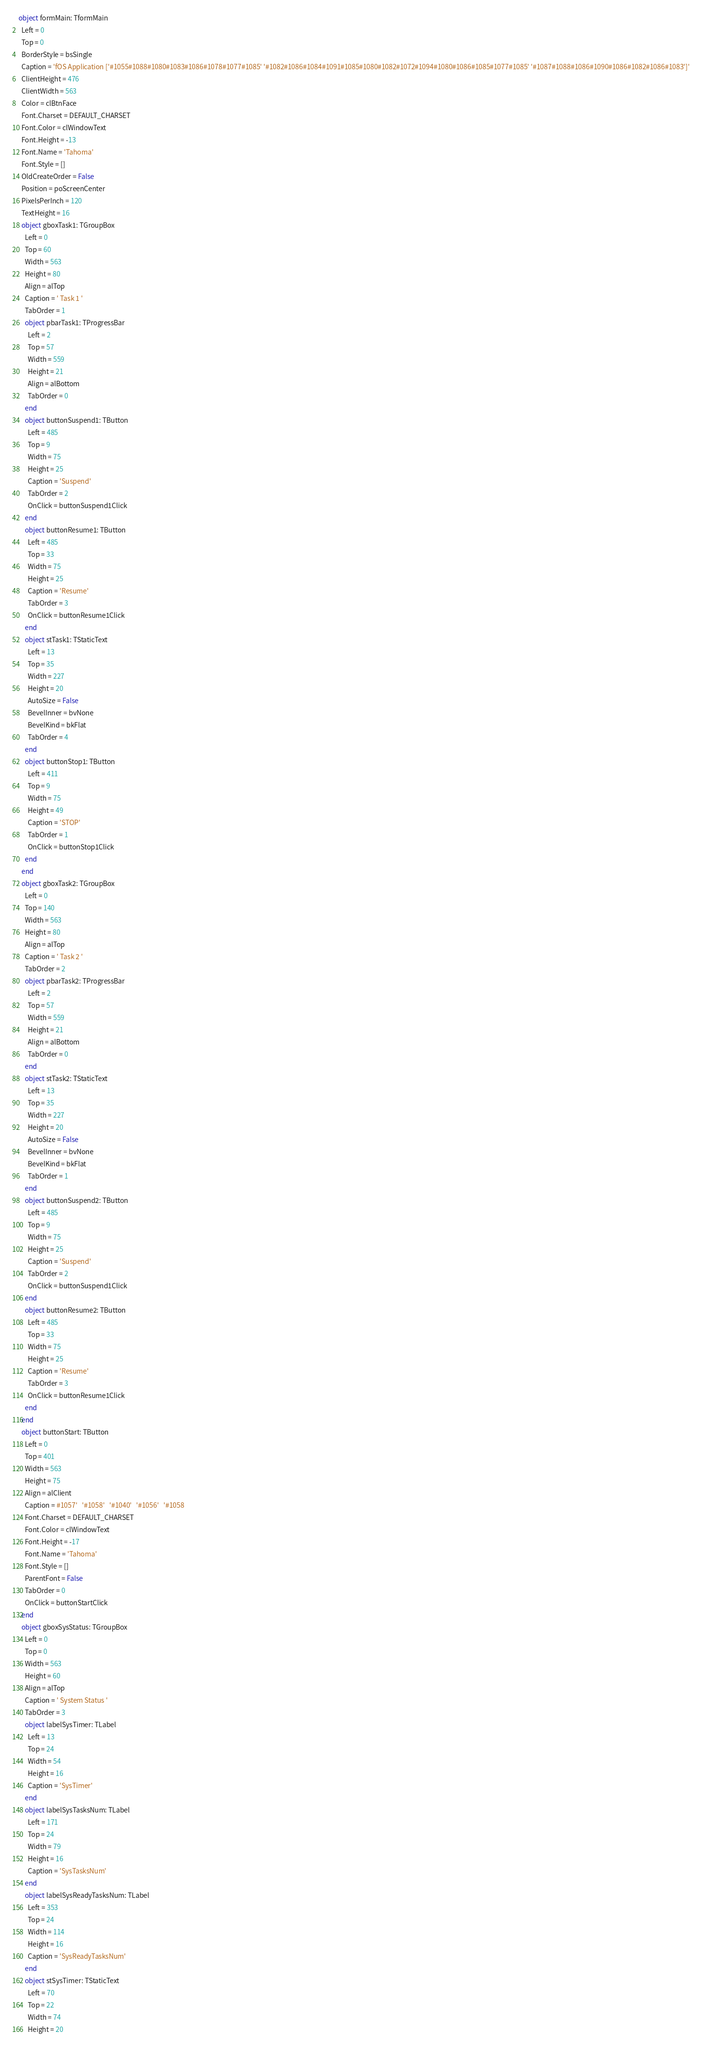<code> <loc_0><loc_0><loc_500><loc_500><_Pascal_>object formMain: TformMain
  Left = 0
  Top = 0
  BorderStyle = bsSingle
  Caption = 'fOS Application ['#1055#1088#1080#1083#1086#1078#1077#1085' '#1082#1086#1084#1091#1085#1080#1082#1072#1094#1080#1086#1085#1077#1085' '#1087#1088#1086#1090#1086#1082#1086#1083']'
  ClientHeight = 476
  ClientWidth = 563
  Color = clBtnFace
  Font.Charset = DEFAULT_CHARSET
  Font.Color = clWindowText
  Font.Height = -13
  Font.Name = 'Tahoma'
  Font.Style = []
  OldCreateOrder = False
  Position = poScreenCenter
  PixelsPerInch = 120
  TextHeight = 16
  object gboxTask1: TGroupBox
    Left = 0
    Top = 60
    Width = 563
    Height = 80
    Align = alTop
    Caption = ' Task 1 '
    TabOrder = 1
    object pbarTask1: TProgressBar
      Left = 2
      Top = 57
      Width = 559
      Height = 21
      Align = alBottom
      TabOrder = 0
    end
    object buttonSuspend1: TButton
      Left = 485
      Top = 9
      Width = 75
      Height = 25
      Caption = 'Suspend'
      TabOrder = 2
      OnClick = buttonSuspend1Click
    end
    object buttonResume1: TButton
      Left = 485
      Top = 33
      Width = 75
      Height = 25
      Caption = 'Resume'
      TabOrder = 3
      OnClick = buttonResume1Click
    end
    object stTask1: TStaticText
      Left = 13
      Top = 35
      Width = 227
      Height = 20
      AutoSize = False
      BevelInner = bvNone
      BevelKind = bkFlat
      TabOrder = 4
    end
    object buttonStop1: TButton
      Left = 411
      Top = 9
      Width = 75
      Height = 49
      Caption = 'STOP'
      TabOrder = 1
      OnClick = buttonStop1Click
    end
  end
  object gboxTask2: TGroupBox
    Left = 0
    Top = 140
    Width = 563
    Height = 80
    Align = alTop
    Caption = ' Task 2 '
    TabOrder = 2
    object pbarTask2: TProgressBar
      Left = 2
      Top = 57
      Width = 559
      Height = 21
      Align = alBottom
      TabOrder = 0
    end
    object stTask2: TStaticText
      Left = 13
      Top = 35
      Width = 227
      Height = 20
      AutoSize = False
      BevelInner = bvNone
      BevelKind = bkFlat
      TabOrder = 1
    end
    object buttonSuspend2: TButton
      Left = 485
      Top = 9
      Width = 75
      Height = 25
      Caption = 'Suspend'
      TabOrder = 2
      OnClick = buttonSuspend1Click
    end
    object buttonResume2: TButton
      Left = 485
      Top = 33
      Width = 75
      Height = 25
      Caption = 'Resume'
      TabOrder = 3
      OnClick = buttonResume1Click
    end
  end
  object buttonStart: TButton
    Left = 0
    Top = 401
    Width = 563
    Height = 75
    Align = alClient
    Caption = #1057'   '#1058'   '#1040'   '#1056'   '#1058
    Font.Charset = DEFAULT_CHARSET
    Font.Color = clWindowText
    Font.Height = -17
    Font.Name = 'Tahoma'
    Font.Style = []
    ParentFont = False
    TabOrder = 0
    OnClick = buttonStartClick
  end
  object gboxSysStatus: TGroupBox
    Left = 0
    Top = 0
    Width = 563
    Height = 60
    Align = alTop
    Caption = ' System Status '
    TabOrder = 3
    object labelSysTimer: TLabel
      Left = 13
      Top = 24
      Width = 54
      Height = 16
      Caption = 'SysTimer'
    end
    object labelSysTasksNum: TLabel
      Left = 171
      Top = 24
      Width = 79
      Height = 16
      Caption = 'SysTasksNum'
    end
    object labelSysReadyTasksNum: TLabel
      Left = 353
      Top = 24
      Width = 114
      Height = 16
      Caption = 'SysReadyTasksNum'
    end
    object stSysTimer: TStaticText
      Left = 70
      Top = 22
      Width = 74
      Height = 20</code> 